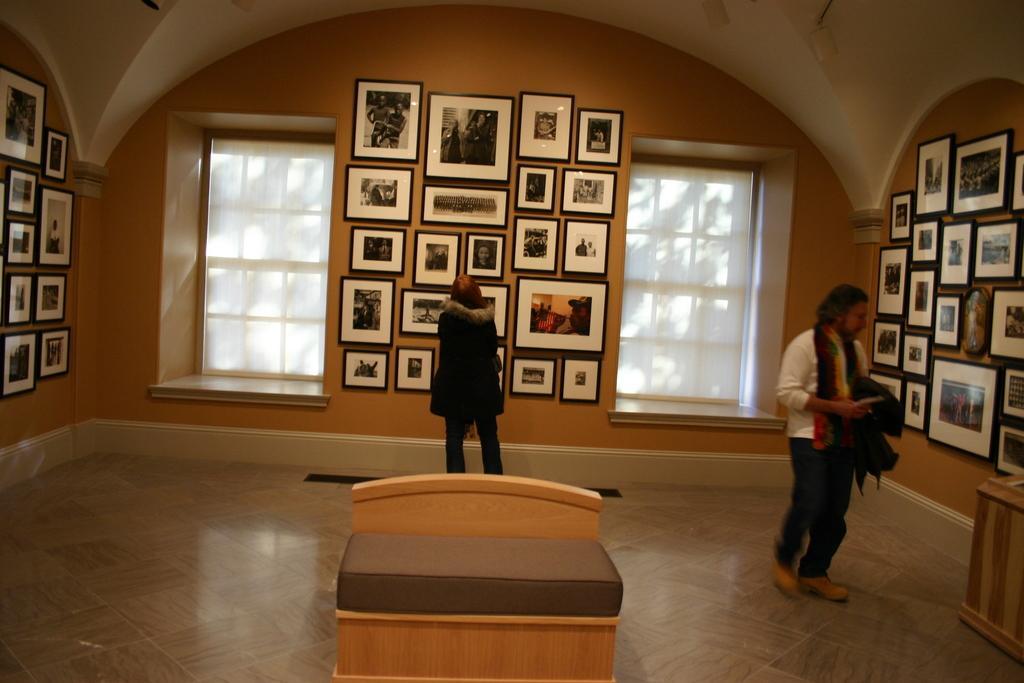Can you describe this image briefly? In this image, we can see people and one of them is wearing a coat and the other is wearing a scarf and holding a coat. In the background, there are frames on the wall and we can see windows and there are stands. At the bottom, there is a floor. 